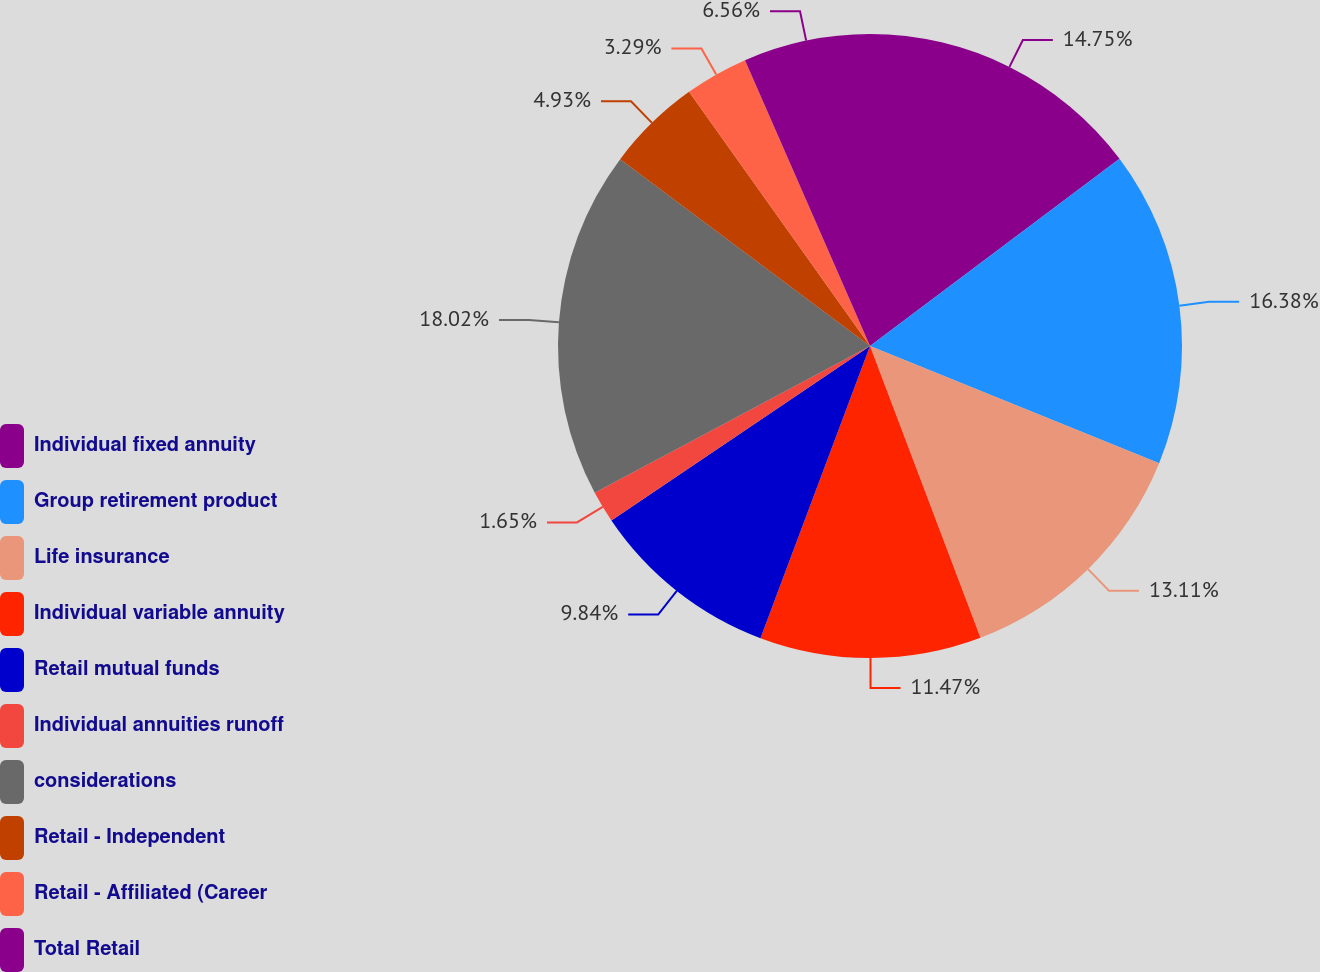Convert chart to OTSL. <chart><loc_0><loc_0><loc_500><loc_500><pie_chart><fcel>Individual fixed annuity<fcel>Group retirement product<fcel>Life insurance<fcel>Individual variable annuity<fcel>Retail mutual funds<fcel>Individual annuities runoff<fcel>considerations<fcel>Retail - Independent<fcel>Retail - Affiliated (Career<fcel>Total Retail<nl><fcel>14.75%<fcel>16.38%<fcel>13.11%<fcel>11.47%<fcel>9.84%<fcel>1.65%<fcel>18.02%<fcel>4.93%<fcel>3.29%<fcel>6.56%<nl></chart> 